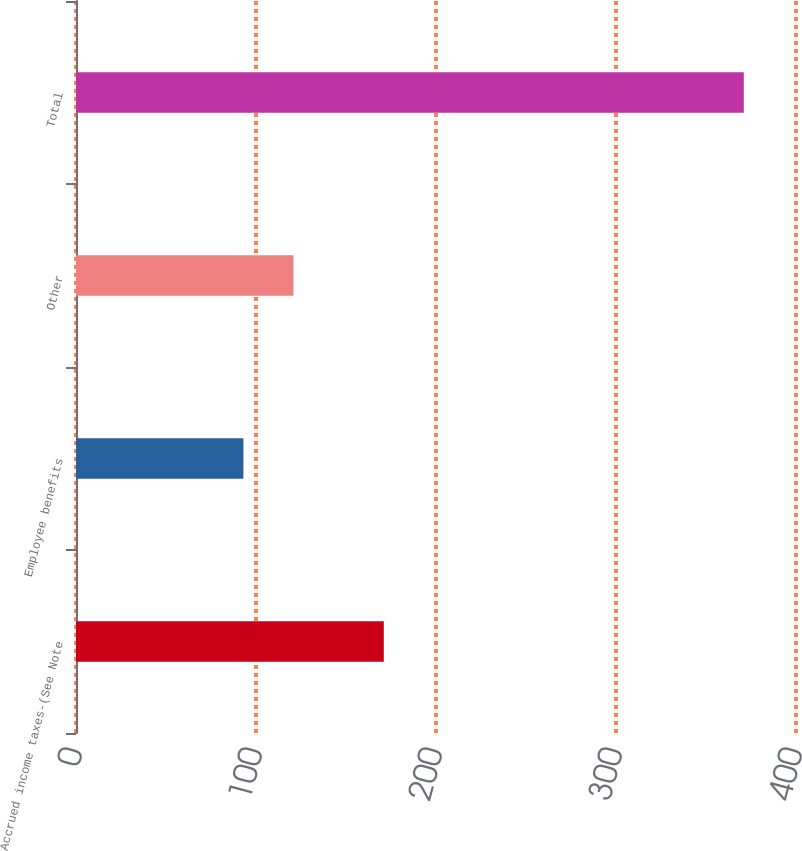Convert chart. <chart><loc_0><loc_0><loc_500><loc_500><bar_chart><fcel>Accrued income taxes-(See Note<fcel>Employee benefits<fcel>Other<fcel>Total<nl><fcel>171<fcel>93<fcel>120.8<fcel>371<nl></chart> 